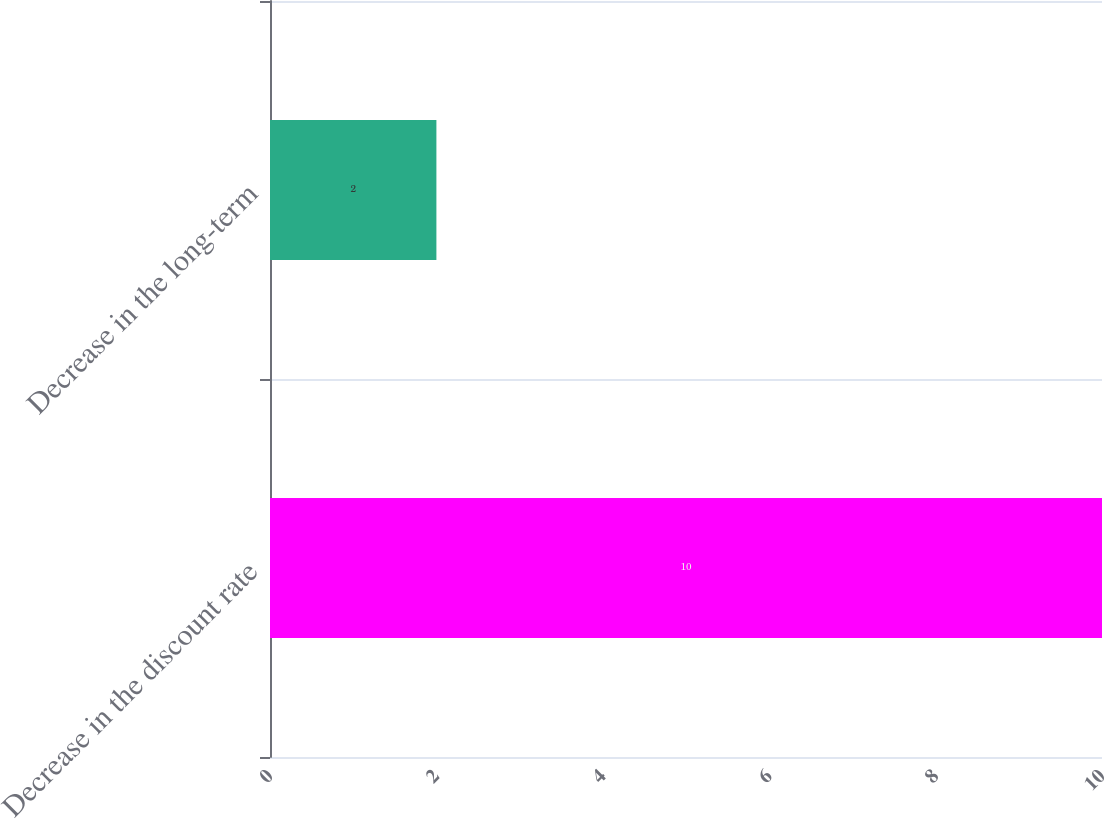<chart> <loc_0><loc_0><loc_500><loc_500><bar_chart><fcel>Decrease in the discount rate<fcel>Decrease in the long-term<nl><fcel>10<fcel>2<nl></chart> 